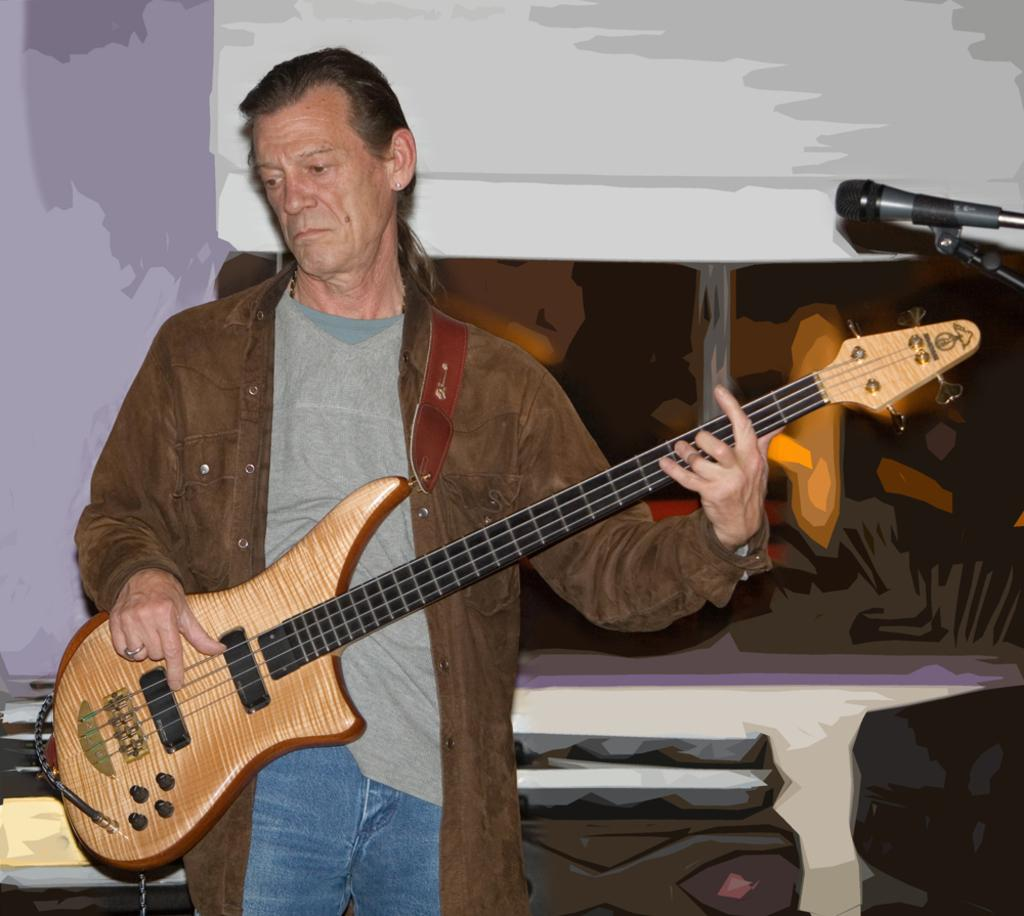What is the main subject of the image? There is a man in the image. What is the man holding in the image? The man is holding a guitar. Can you see the man's pet in the image? There is no pet visible in the image. Is the man standing near a river in the image? There is no river present in the image. 